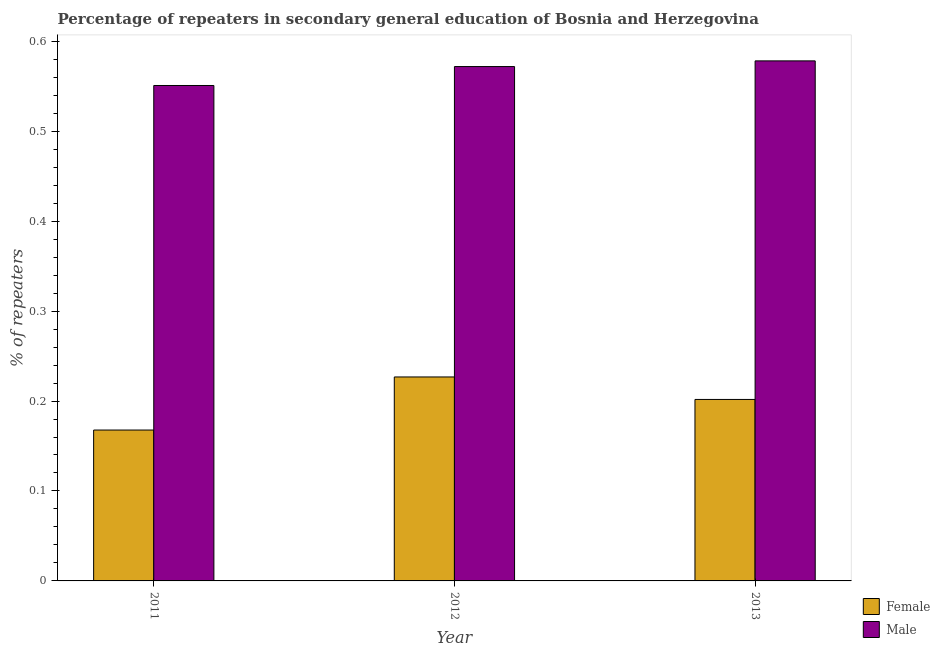How many different coloured bars are there?
Provide a succinct answer. 2. Are the number of bars on each tick of the X-axis equal?
Make the answer very short. Yes. How many bars are there on the 2nd tick from the right?
Provide a short and direct response. 2. What is the label of the 2nd group of bars from the left?
Your answer should be very brief. 2012. In how many cases, is the number of bars for a given year not equal to the number of legend labels?
Ensure brevity in your answer.  0. What is the percentage of female repeaters in 2011?
Your answer should be compact. 0.17. Across all years, what is the maximum percentage of male repeaters?
Offer a very short reply. 0.58. Across all years, what is the minimum percentage of male repeaters?
Ensure brevity in your answer.  0.55. In which year was the percentage of female repeaters minimum?
Your answer should be very brief. 2011. What is the total percentage of male repeaters in the graph?
Your answer should be very brief. 1.7. What is the difference between the percentage of male repeaters in 2012 and that in 2013?
Keep it short and to the point. -0.01. What is the difference between the percentage of male repeaters in 2011 and the percentage of female repeaters in 2013?
Provide a succinct answer. -0.03. What is the average percentage of male repeaters per year?
Give a very brief answer. 0.57. In the year 2011, what is the difference between the percentage of female repeaters and percentage of male repeaters?
Ensure brevity in your answer.  0. In how many years, is the percentage of female repeaters greater than 0.56 %?
Make the answer very short. 0. What is the ratio of the percentage of male repeaters in 2011 to that in 2013?
Offer a very short reply. 0.95. Is the difference between the percentage of female repeaters in 2012 and 2013 greater than the difference between the percentage of male repeaters in 2012 and 2013?
Make the answer very short. No. What is the difference between the highest and the second highest percentage of male repeaters?
Make the answer very short. 0.01. What is the difference between the highest and the lowest percentage of male repeaters?
Your response must be concise. 0.03. What does the 1st bar from the right in 2012 represents?
Provide a succinct answer. Male. How many bars are there?
Your answer should be very brief. 6. Are all the bars in the graph horizontal?
Make the answer very short. No. How many years are there in the graph?
Offer a terse response. 3. What is the difference between two consecutive major ticks on the Y-axis?
Offer a terse response. 0.1. Are the values on the major ticks of Y-axis written in scientific E-notation?
Make the answer very short. No. Does the graph contain any zero values?
Give a very brief answer. No. How many legend labels are there?
Provide a succinct answer. 2. What is the title of the graph?
Offer a terse response. Percentage of repeaters in secondary general education of Bosnia and Herzegovina. What is the label or title of the X-axis?
Offer a very short reply. Year. What is the label or title of the Y-axis?
Offer a very short reply. % of repeaters. What is the % of repeaters in Female in 2011?
Your response must be concise. 0.17. What is the % of repeaters of Male in 2011?
Give a very brief answer. 0.55. What is the % of repeaters of Female in 2012?
Your response must be concise. 0.23. What is the % of repeaters in Male in 2012?
Provide a short and direct response. 0.57. What is the % of repeaters of Female in 2013?
Give a very brief answer. 0.2. What is the % of repeaters in Male in 2013?
Provide a short and direct response. 0.58. Across all years, what is the maximum % of repeaters of Female?
Give a very brief answer. 0.23. Across all years, what is the maximum % of repeaters of Male?
Your response must be concise. 0.58. Across all years, what is the minimum % of repeaters of Female?
Ensure brevity in your answer.  0.17. Across all years, what is the minimum % of repeaters of Male?
Ensure brevity in your answer.  0.55. What is the total % of repeaters in Female in the graph?
Your response must be concise. 0.6. What is the total % of repeaters of Male in the graph?
Ensure brevity in your answer.  1.7. What is the difference between the % of repeaters in Female in 2011 and that in 2012?
Give a very brief answer. -0.06. What is the difference between the % of repeaters of Male in 2011 and that in 2012?
Ensure brevity in your answer.  -0.02. What is the difference between the % of repeaters of Female in 2011 and that in 2013?
Offer a very short reply. -0.03. What is the difference between the % of repeaters in Male in 2011 and that in 2013?
Give a very brief answer. -0.03. What is the difference between the % of repeaters of Female in 2012 and that in 2013?
Offer a very short reply. 0.03. What is the difference between the % of repeaters of Male in 2012 and that in 2013?
Make the answer very short. -0.01. What is the difference between the % of repeaters in Female in 2011 and the % of repeaters in Male in 2012?
Your answer should be compact. -0.4. What is the difference between the % of repeaters in Female in 2011 and the % of repeaters in Male in 2013?
Give a very brief answer. -0.41. What is the difference between the % of repeaters in Female in 2012 and the % of repeaters in Male in 2013?
Provide a short and direct response. -0.35. What is the average % of repeaters of Female per year?
Your answer should be very brief. 0.2. What is the average % of repeaters of Male per year?
Ensure brevity in your answer.  0.57. In the year 2011, what is the difference between the % of repeaters of Female and % of repeaters of Male?
Your answer should be very brief. -0.38. In the year 2012, what is the difference between the % of repeaters of Female and % of repeaters of Male?
Provide a succinct answer. -0.35. In the year 2013, what is the difference between the % of repeaters of Female and % of repeaters of Male?
Keep it short and to the point. -0.38. What is the ratio of the % of repeaters of Female in 2011 to that in 2012?
Your answer should be very brief. 0.74. What is the ratio of the % of repeaters of Male in 2011 to that in 2012?
Provide a short and direct response. 0.96. What is the ratio of the % of repeaters of Female in 2011 to that in 2013?
Provide a short and direct response. 0.83. What is the ratio of the % of repeaters in Male in 2011 to that in 2013?
Keep it short and to the point. 0.95. What is the ratio of the % of repeaters in Female in 2012 to that in 2013?
Your response must be concise. 1.12. What is the ratio of the % of repeaters in Male in 2012 to that in 2013?
Ensure brevity in your answer.  0.99. What is the difference between the highest and the second highest % of repeaters of Female?
Offer a very short reply. 0.03. What is the difference between the highest and the second highest % of repeaters in Male?
Offer a terse response. 0.01. What is the difference between the highest and the lowest % of repeaters in Female?
Make the answer very short. 0.06. What is the difference between the highest and the lowest % of repeaters of Male?
Ensure brevity in your answer.  0.03. 